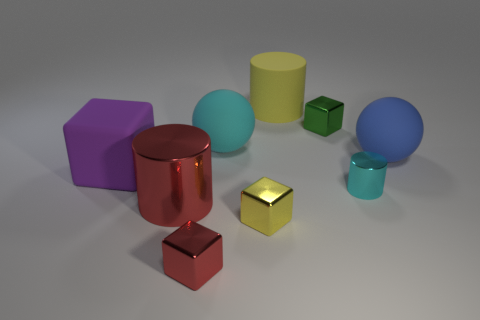How many objects are big cylinders in front of the green metallic thing or large red metallic cylinders?
Your answer should be very brief. 1. There is a small shiny block behind the large purple cube; is it the same color as the tiny cylinder?
Provide a succinct answer. No. What size is the rubber object that is the same shape as the tiny cyan metallic object?
Offer a terse response. Large. What is the color of the metallic cylinder that is behind the big cylinder that is in front of the cyan object that is on the left side of the tiny green metallic cube?
Your answer should be compact. Cyan. Are the yellow cylinder and the large cyan object made of the same material?
Offer a very short reply. Yes. Is there a green metallic block that is in front of the big rubber sphere on the left side of the shiny cylinder on the right side of the small red block?
Keep it short and to the point. No. Does the matte cube have the same color as the big shiny object?
Keep it short and to the point. No. Are there fewer tiny cyan cylinders than tiny red cylinders?
Give a very brief answer. No. Is the material of the big object that is on the right side of the green block the same as the yellow object that is behind the blue rubber object?
Your response must be concise. Yes. Are there fewer purple matte things in front of the large red metallic thing than small purple matte things?
Offer a very short reply. No. 